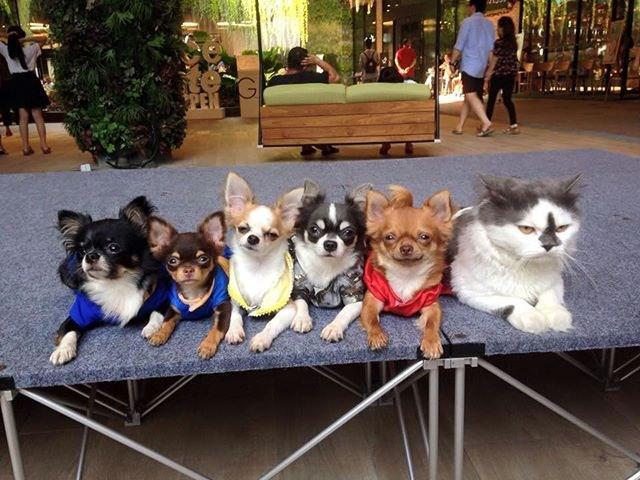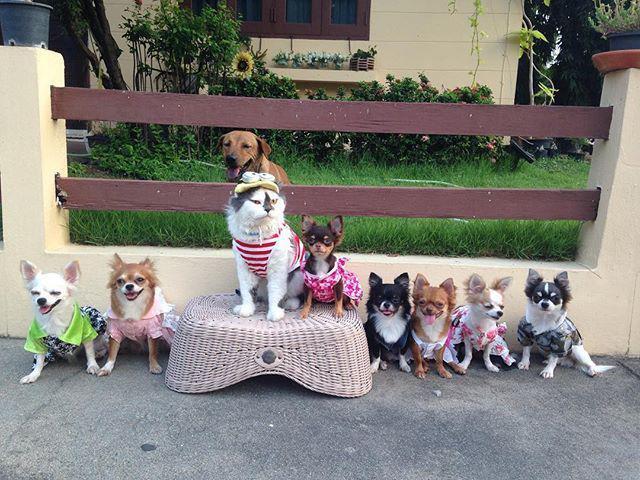The first image is the image on the left, the second image is the image on the right. Given the left and right images, does the statement "A person walks toward the camera near a pack of small animals that walk on the same paved surface." hold true? Answer yes or no. No. The first image is the image on the left, the second image is the image on the right. For the images shown, is this caption "The right image contains at least eight dogs." true? Answer yes or no. Yes. 